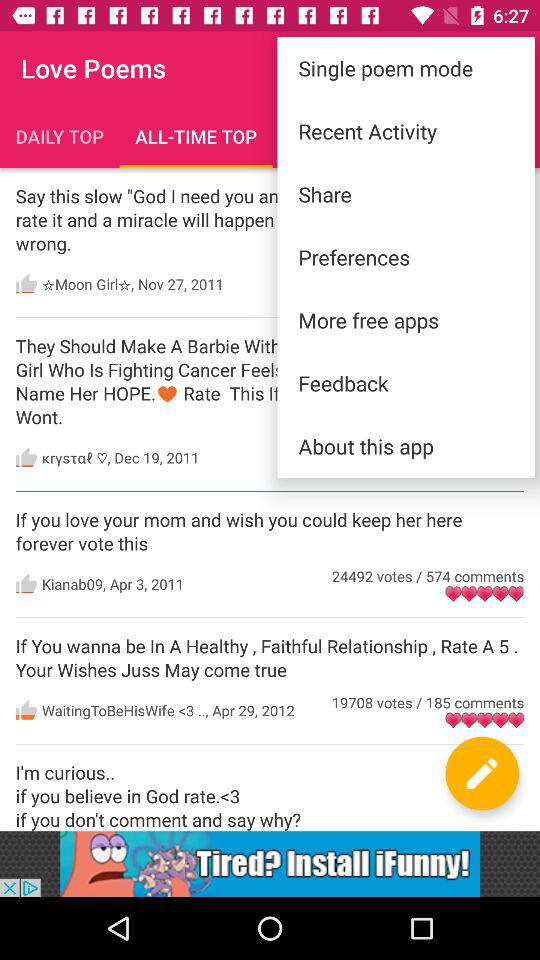When was the poem by "WaitingToBeHisWife <3.." posted? The poem by "WaitingToBeHisWife <3.." was posted on April 29, 2012. 